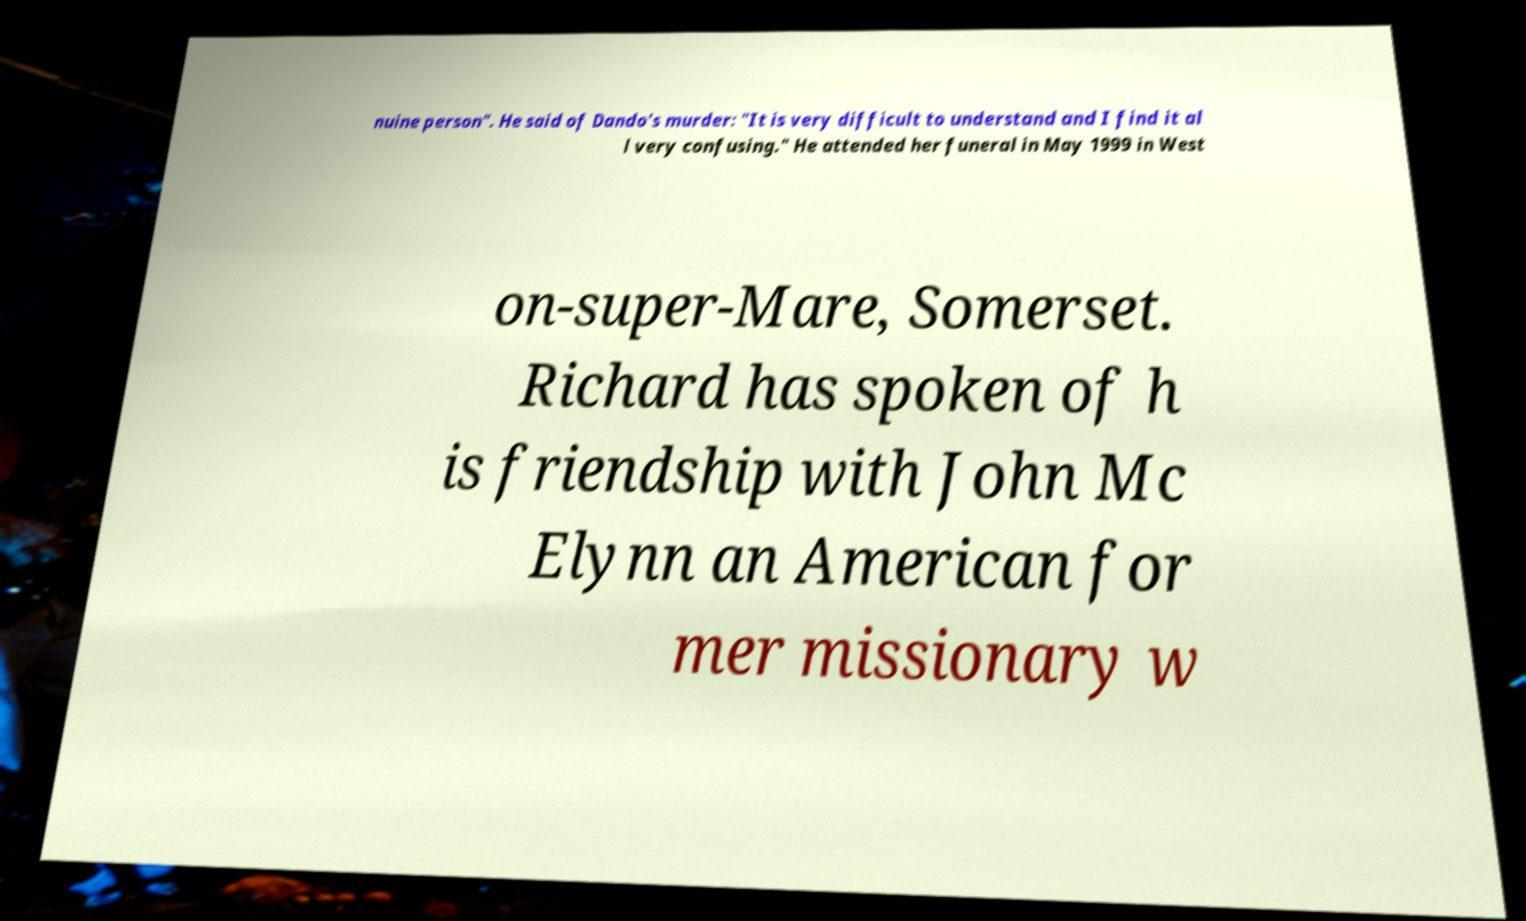Could you assist in decoding the text presented in this image and type it out clearly? nuine person". He said of Dando's murder: "It is very difficult to understand and I find it al l very confusing." He attended her funeral in May 1999 in West on-super-Mare, Somerset. Richard has spoken of h is friendship with John Mc Elynn an American for mer missionary w 